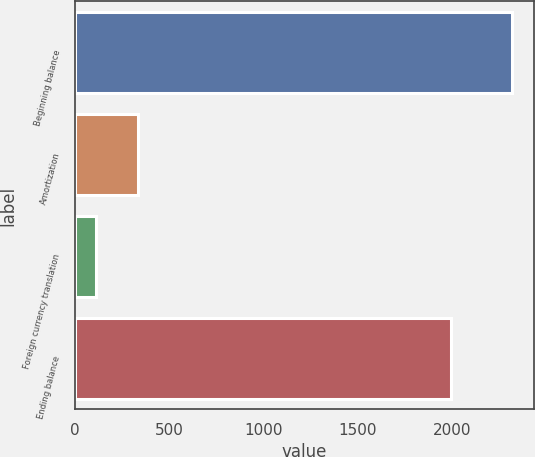<chart> <loc_0><loc_0><loc_500><loc_500><bar_chart><fcel>Beginning balance<fcel>Amortization<fcel>Foreign currency translation<fcel>Ending balance<nl><fcel>2321<fcel>331.1<fcel>110<fcel>1998<nl></chart> 